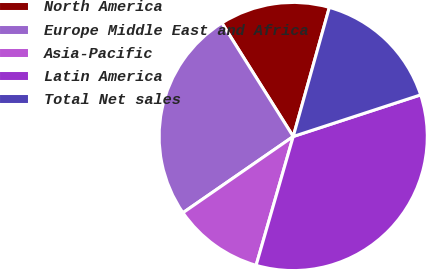Convert chart. <chart><loc_0><loc_0><loc_500><loc_500><pie_chart><fcel>North America<fcel>Europe Middle East and Africa<fcel>Asia-Pacific<fcel>Latin America<fcel>Total Net sales<nl><fcel>13.27%<fcel>25.7%<fcel>10.91%<fcel>34.49%<fcel>15.63%<nl></chart> 